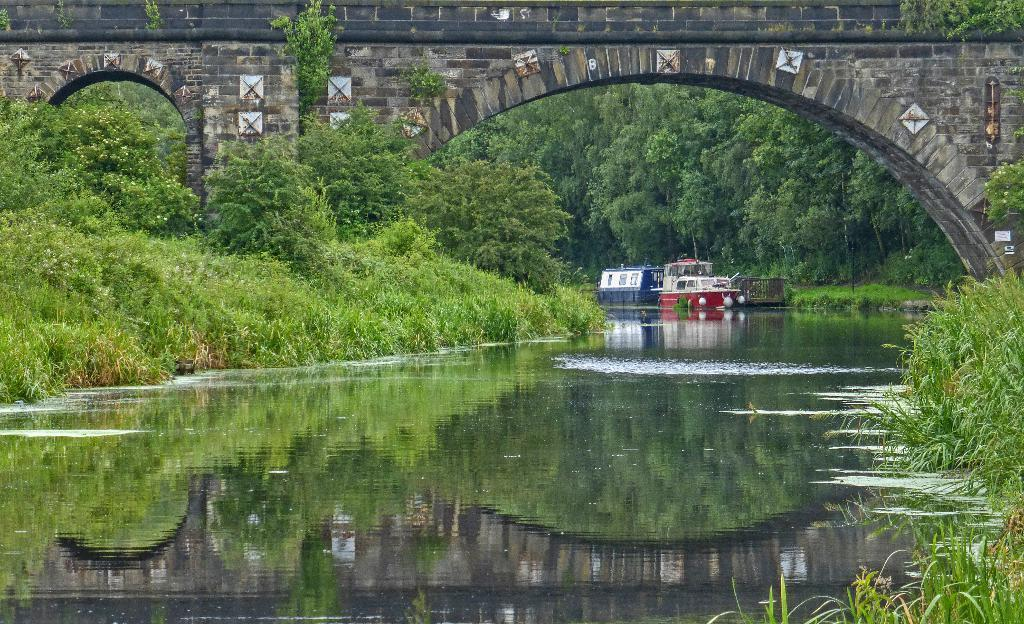What type of objects can be seen in the image that resemble boats? There are objects in the image that resemble boats. Where are the boats located in the image? The boats are on the water. What structure is visible in front of the boats? There is a bridge in front of the boats. What type of vegetation is visible behind the boats? There are trees and grass behind the boats. How many levels of grass are visible behind the boats? There is no indication of multiple levels of grass in the image; it appears to be a single layer of grass. 